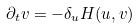<formula> <loc_0><loc_0><loc_500><loc_500>\partial _ { t } v = - \delta _ { u } H ( u , v )</formula> 